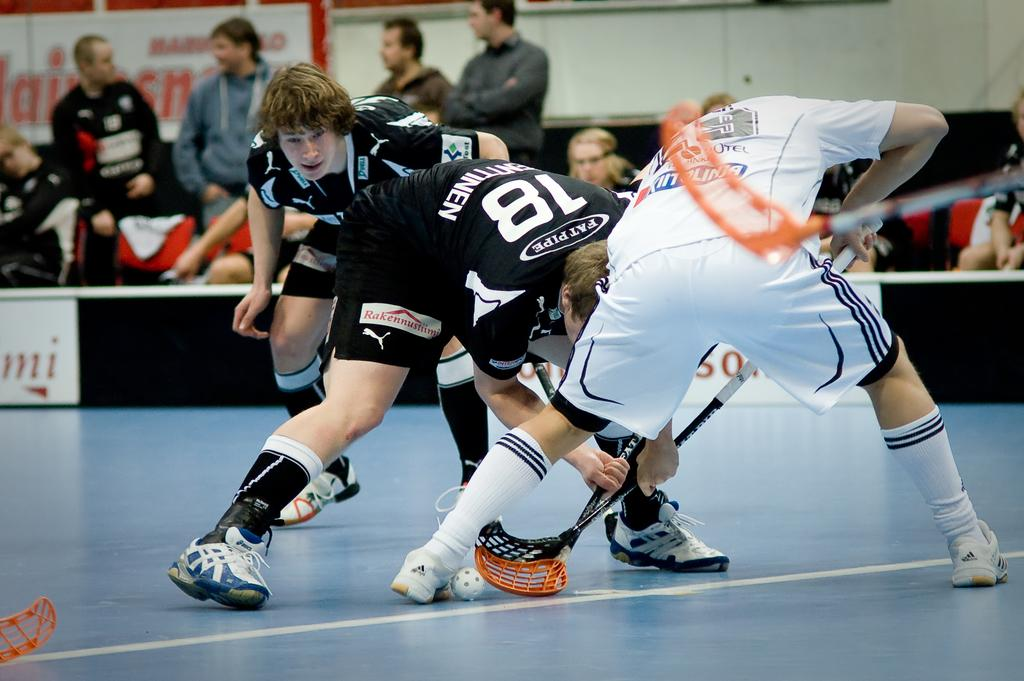Provide a one-sentence caption for the provided image. Three Lacrosse players playing indoors, one of whom is Pat Pipe #18. 